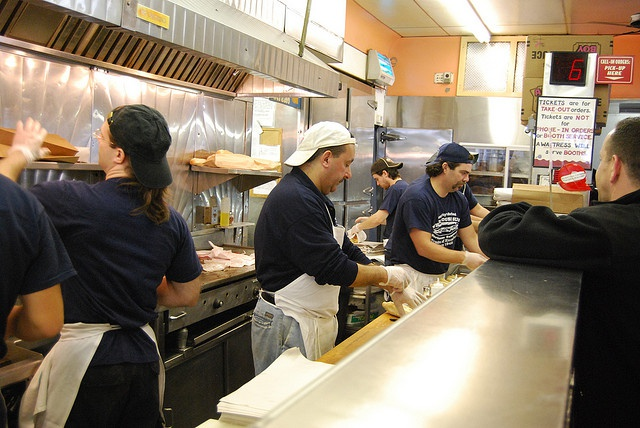Describe the objects in this image and their specific colors. I can see people in maroon, black, tan, and gray tones, people in maroon, black, gray, and tan tones, people in maroon, black, gray, darkgray, and tan tones, oven in maroon, black, darkgreen, and gray tones, and people in maroon, black, and brown tones in this image. 